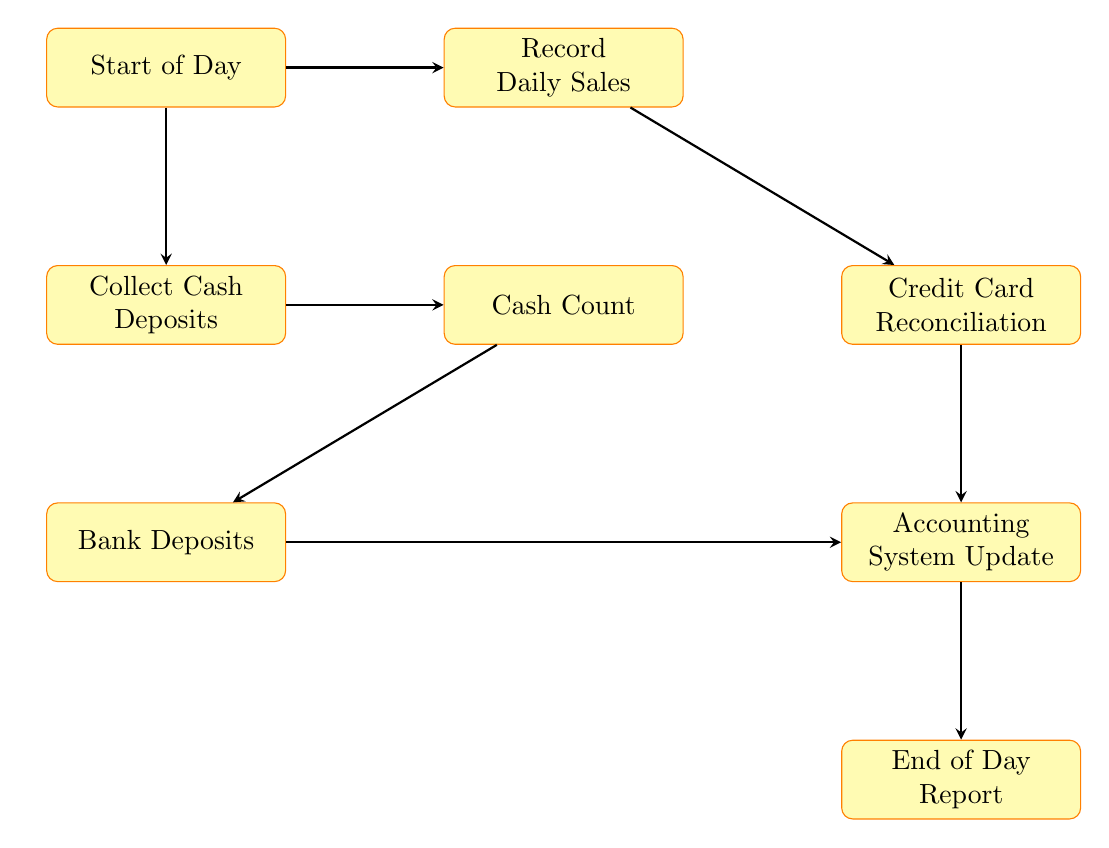What is the first step of the daily sales reconciliation process? The first step is identified at the top of the flow chart as "Start of Day." This node indicates the initial action taken to prepare for the daily activities.
Answer: Start of Day How many process nodes are present in the flow chart? By counting each distinct process box in the diagram, we can see that there are a total of eight nodes including "Start of Day" and "End of Day Report."
Answer: Eight What is the last step in the reconciliation process? The last step can be found at the bottom of the flow chart, denoted as "End of Day Report," which signifies the conclusion of all daily reconciliation activities.
Answer: End of Day Report Which two processes follow the "Collect Cash Deposits"? In the sequence of the flow chart, after "Collect Cash Deposits," the next two processes are "Cash Count" and "Bank Deposits" that arise directly from the cash collection.
Answer: Cash Count, Bank Deposits What action is taken after all cash is counted? Following the "Cash Count," the next action outlined in the flow chart is "Bank Deposits," indicating the collected cash is deposited into the bank account after counting.
Answer: Bank Deposits Which processes are connected to the "Accounting System Update"? The "Accounting System Update" is linked to "Credit Card Reconciliation" and "Bank Deposits," as both of these actions need to be completed before updating the accounting system with reconciled data.
Answer: Credit Card Reconciliation, Bank Deposits What is the relationship between "Record Daily Sales" and "Credit Card Reconciliation"? The diagram shows that "Record Daily Sales" feeds directly into "Credit Card Reconciliation," meaning that the sales recorded during the day are matched with the corresponding credit card transactions.
Answer: Directly feeds into How many arrows are used to connect the nodes in the flow chart? By examining the flow lines connecting each process, it is evident that there are seven arrows demonstrating the flow from one process to the next throughout the chart.
Answer: Seven 